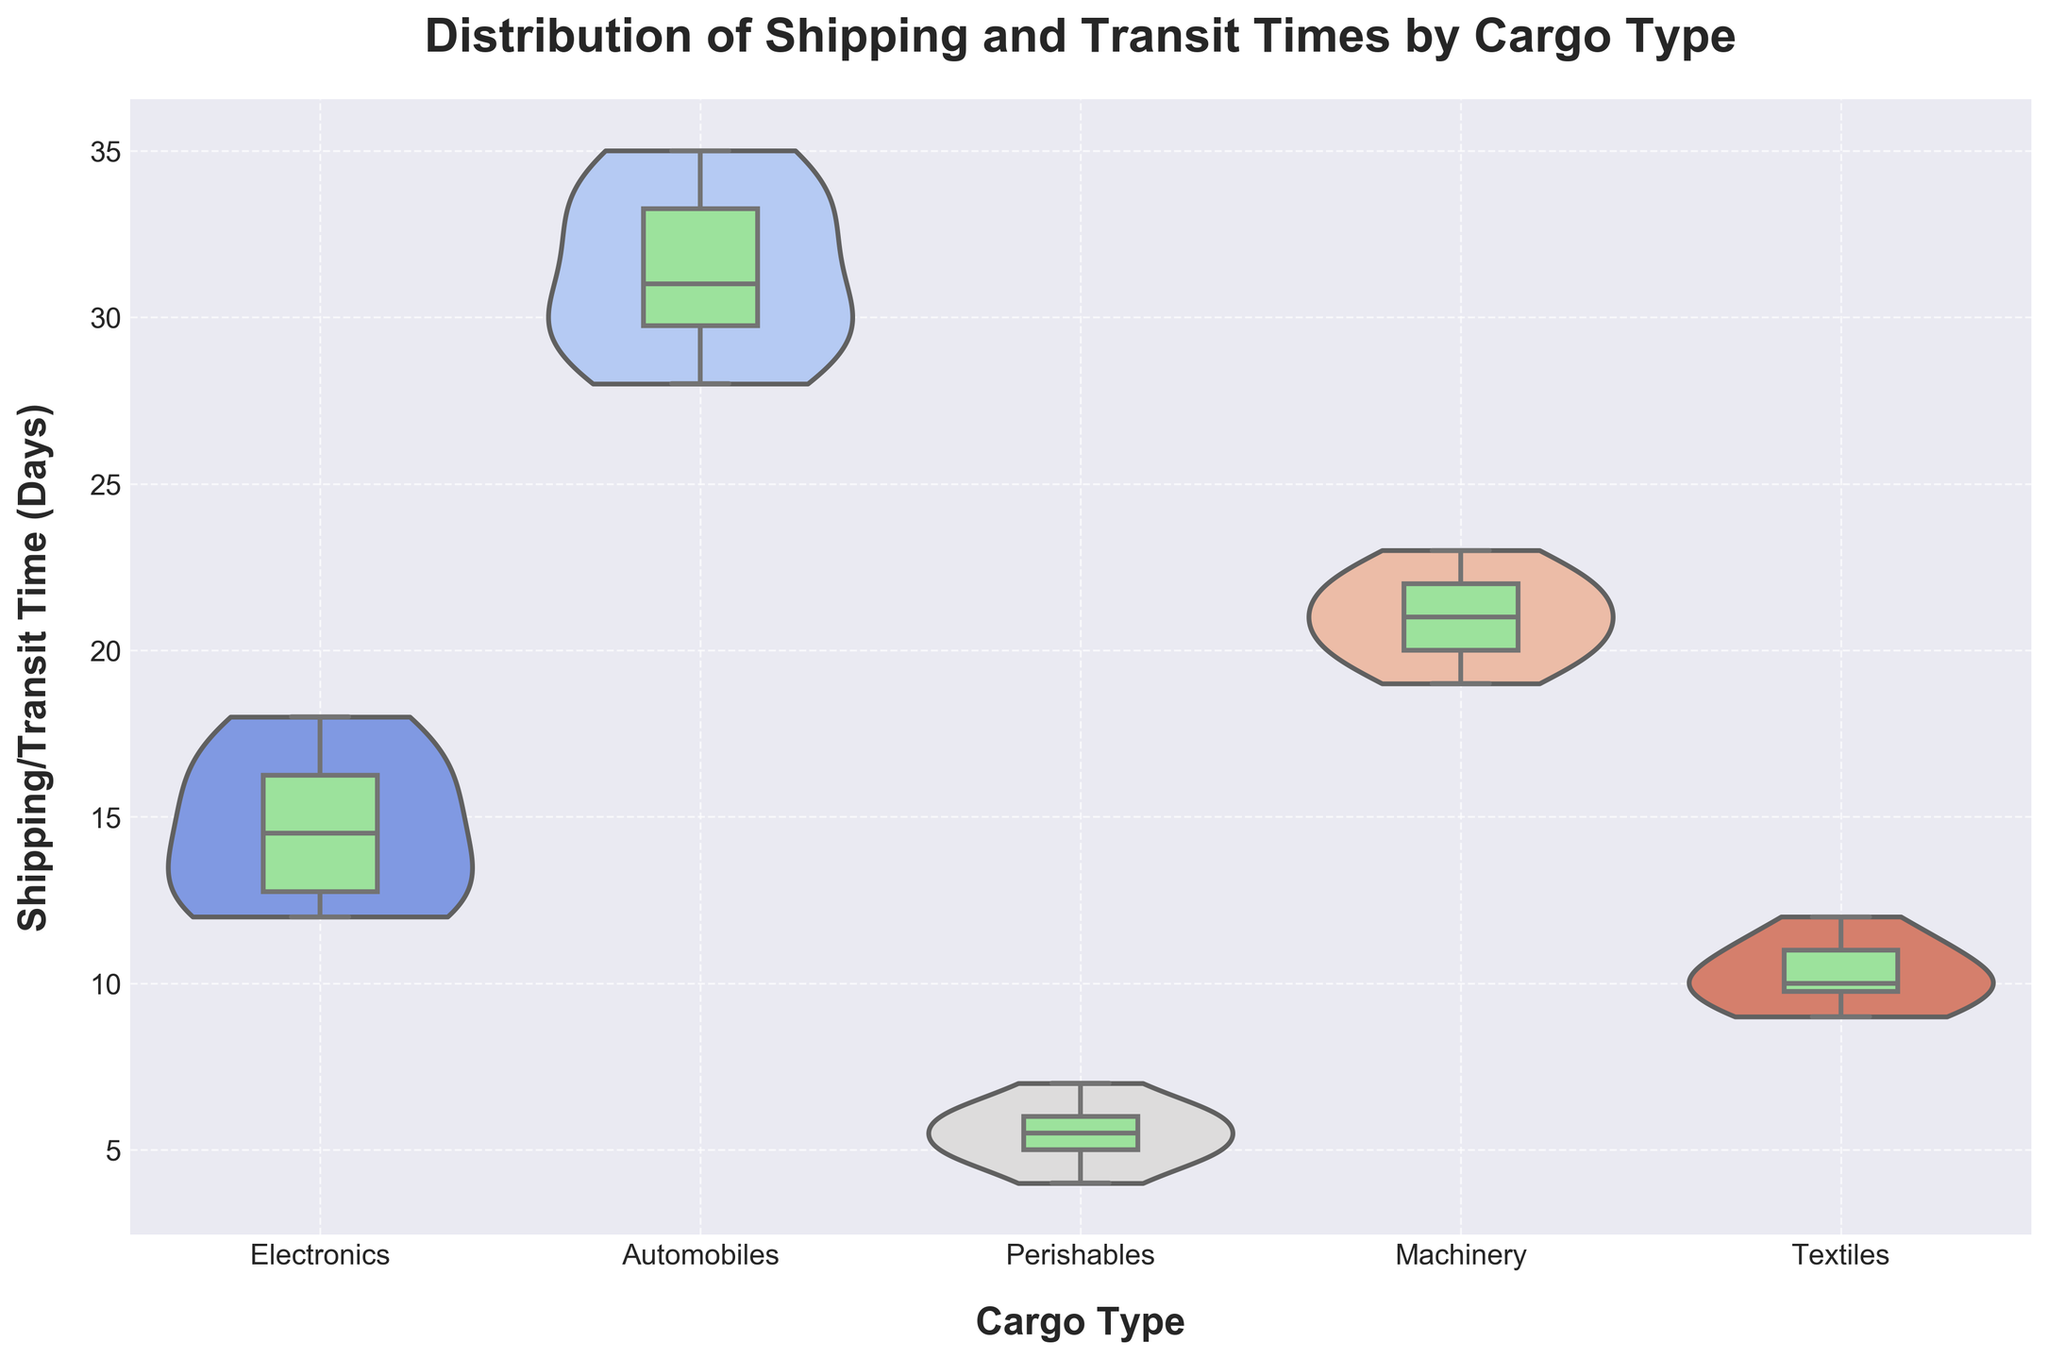What's the title of the chart? The title of the chart is placed at the top and often provides a summary of what the chart depicts. In this case, it reads 'Distribution of Shipping and Transit Times by Cargo Type'.
Answer: Distribution of Shipping and Transit Times by Cargo Type What is the y-axis label? The y-axis label specifies the variable being measured on the vertical axis, which in this chart is 'Shipping/Transit Time (Days)'.
Answer: Shipping/Transit Time (Days) Which cargo type has the highest median shipping/transit time? To find the cargo type with the highest median shipping/transit time, look at the white dots within the box plots. The highest median value among the white dots is for 'Automobiles'.
Answer: Automobiles What is the range of transit times for Perishables? The range of transit times can be determined by looking at the extremes of the Perishables' violin plot. The minimum value is 4 days and the maximum is 7 days.
Answer: 4-7 days How do the shapes of the violin plots for Electronics and Machinery differ? Observing the violin plots, Electronics show a wider spread with more density around the lower end (12-15 days), while Machinery has a slightly narrower and more evenly distributed density between 19 and 23 days.
Answer: Electronics: wider spread, Machinery: narrow and even spread Which cargo type has the widest distribution of shipping/transit times? The cargo type with the most spread out (widest) violin plot represents the widest distribution. 'Automobiles' has the widest distribution, ranging from 28 to 35 days.
Answer: Automobiles Compare the median shipping/transit times of Textiles and Perishables. Which one is higher? The median is indicated by the white dots within the box plots. The median for Textiles is around 10 days while for Perishables it is around 5 days, meaning Textiles has a higher median.
Answer: Textiles Which cargo type has the most symmetrical shipping/transit time distribution? Symmetry in a violin plot is shown by a more uniform spread on both sides of the plot’s centerline. Both 'Textiles' and 'Machinery' show more symmetrical distributions compared to others, but 'Textiles' is particularly balanced.
Answer: Textiles What are the lower and upper quartiles for the Electronics cargo type? The lower quartile (25th percentile) and the upper quartile (75th percentile) are identified by the edges of the box in the box plot for Electronics. These are approximately 13 and 16 days respectively.
Answer: 13-16 days 